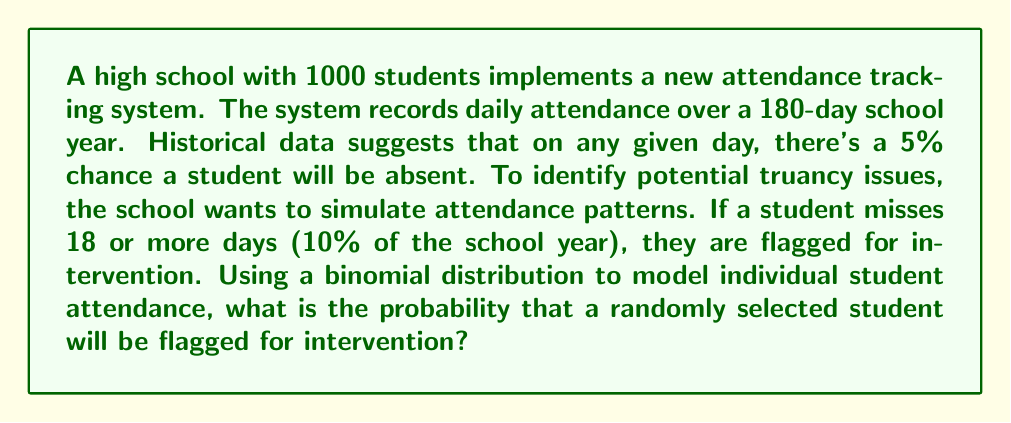Can you solve this math problem? To solve this problem, we'll use the binomial distribution and follow these steps:

1) First, let's identify the parameters of our binomial distribution:
   $n = 180$ (number of school days)
   $p = 0.05$ (probability of being absent on any given day)
   $q = 1 - p = 0.95$ (probability of attending on any given day)

2) We want to find the probability of a student missing 18 or more days. This is equivalent to the probability of not missing 17 or fewer days.

3) Let $X$ be the random variable representing the number of absences. We need to calculate:

   $P(X \geq 18) = 1 - P(X \leq 17)$

4) Using the cumulative binomial distribution function:

   $P(X \leq 17) = \sum_{k=0}^{17} \binom{180}{k} (0.05)^k (0.95)^{180-k}$

5) This sum is complex to calculate by hand, so we would typically use statistical software or a calculator with a binomial cumulative distribution function.

6) Using such a tool, we find that:

   $P(X \leq 17) \approx 0.9419$

7) Therefore, the probability of being flagged for intervention is:

   $P(X \geq 18) = 1 - P(X \leq 17) = 1 - 0.9419 \approx 0.0581$

This means there's about a 5.81% chance that a randomly selected student will be flagged for intervention based on this attendance model.
Answer: 0.0581 or 5.81% 